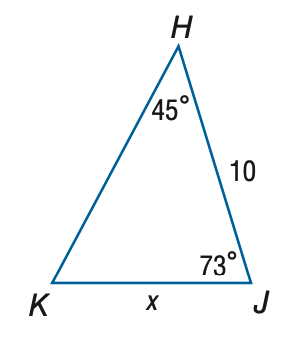Answer the mathemtical geometry problem and directly provide the correct option letter.
Question: Find x. Round to the nearest tenth.
Choices: A: 7.4 B: 8.0 C: 12.5 D: 13.5 B 